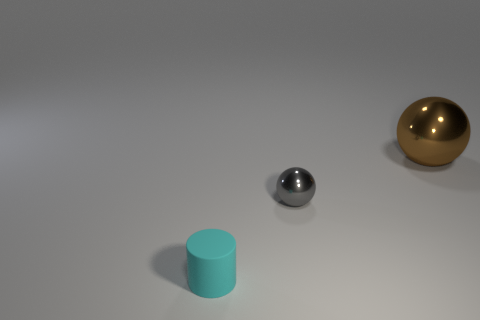Add 2 small gray metal objects. How many objects exist? 5 Subtract all spheres. How many objects are left? 1 Subtract all red spheres. Subtract all red cylinders. How many spheres are left? 2 Subtract all brown cylinders. Subtract all cyan matte cylinders. How many objects are left? 2 Add 2 gray balls. How many gray balls are left? 3 Add 2 gray metal spheres. How many gray metal spheres exist? 3 Subtract 0 purple cylinders. How many objects are left? 3 